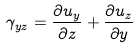Convert formula to latex. <formula><loc_0><loc_0><loc_500><loc_500>\gamma _ { y z } = \frac { \partial u _ { y } } { \partial z } + \frac { \partial u _ { z } } { \partial y }</formula> 